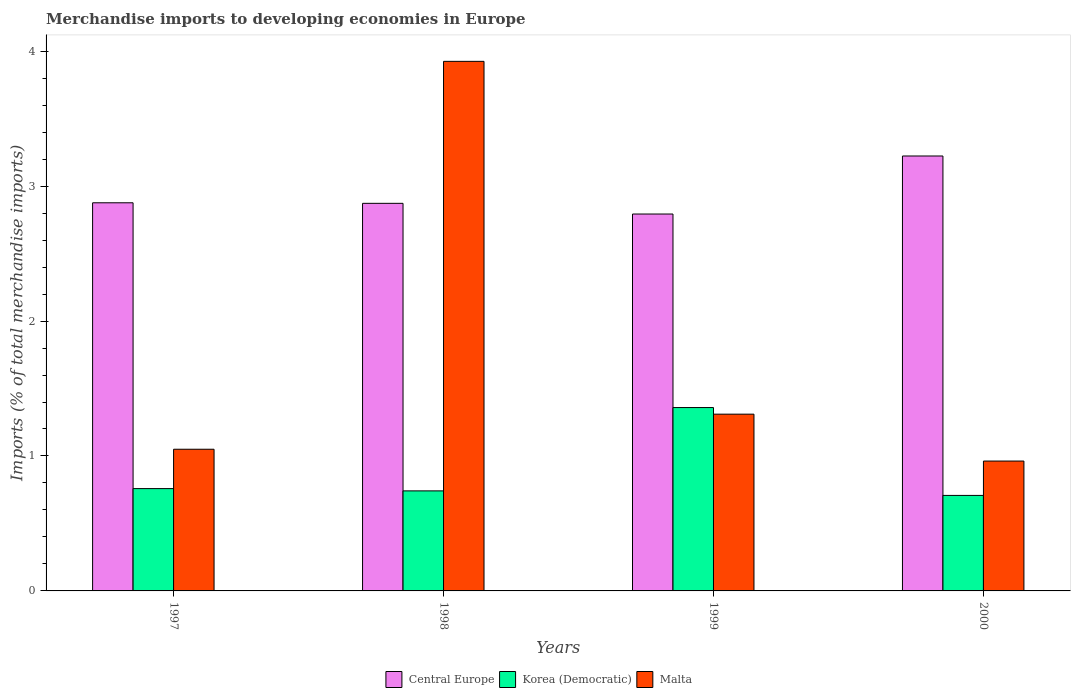How many groups of bars are there?
Your response must be concise. 4. Are the number of bars on each tick of the X-axis equal?
Make the answer very short. Yes. How many bars are there on the 2nd tick from the left?
Your answer should be compact. 3. How many bars are there on the 1st tick from the right?
Offer a very short reply. 3. In how many cases, is the number of bars for a given year not equal to the number of legend labels?
Your answer should be very brief. 0. What is the percentage total merchandise imports in Central Europe in 1999?
Your answer should be very brief. 2.79. Across all years, what is the maximum percentage total merchandise imports in Malta?
Make the answer very short. 3.92. Across all years, what is the minimum percentage total merchandise imports in Korea (Democratic)?
Provide a short and direct response. 0.71. What is the total percentage total merchandise imports in Korea (Democratic) in the graph?
Your answer should be compact. 3.57. What is the difference between the percentage total merchandise imports in Central Europe in 1997 and that in 2000?
Your answer should be very brief. -0.35. What is the difference between the percentage total merchandise imports in Malta in 2000 and the percentage total merchandise imports in Central Europe in 1997?
Make the answer very short. -1.91. What is the average percentage total merchandise imports in Korea (Democratic) per year?
Your answer should be very brief. 0.89. In the year 1998, what is the difference between the percentage total merchandise imports in Korea (Democratic) and percentage total merchandise imports in Central Europe?
Provide a succinct answer. -2.13. In how many years, is the percentage total merchandise imports in Central Europe greater than 3 %?
Provide a succinct answer. 1. What is the ratio of the percentage total merchandise imports in Central Europe in 1999 to that in 2000?
Your answer should be very brief. 0.87. Is the difference between the percentage total merchandise imports in Korea (Democratic) in 1998 and 1999 greater than the difference between the percentage total merchandise imports in Central Europe in 1998 and 1999?
Offer a terse response. No. What is the difference between the highest and the second highest percentage total merchandise imports in Central Europe?
Make the answer very short. 0.35. What is the difference between the highest and the lowest percentage total merchandise imports in Malta?
Keep it short and to the point. 2.96. In how many years, is the percentage total merchandise imports in Korea (Democratic) greater than the average percentage total merchandise imports in Korea (Democratic) taken over all years?
Your answer should be very brief. 1. What does the 3rd bar from the left in 1997 represents?
Your response must be concise. Malta. What does the 1st bar from the right in 1998 represents?
Your answer should be compact. Malta. How many bars are there?
Provide a short and direct response. 12. Where does the legend appear in the graph?
Give a very brief answer. Bottom center. How are the legend labels stacked?
Keep it short and to the point. Horizontal. What is the title of the graph?
Ensure brevity in your answer.  Merchandise imports to developing economies in Europe. Does "Zimbabwe" appear as one of the legend labels in the graph?
Ensure brevity in your answer.  No. What is the label or title of the Y-axis?
Offer a terse response. Imports (% of total merchandise imports). What is the Imports (% of total merchandise imports) in Central Europe in 1997?
Ensure brevity in your answer.  2.88. What is the Imports (% of total merchandise imports) of Korea (Democratic) in 1997?
Your answer should be compact. 0.76. What is the Imports (% of total merchandise imports) in Malta in 1997?
Ensure brevity in your answer.  1.05. What is the Imports (% of total merchandise imports) in Central Europe in 1998?
Offer a very short reply. 2.87. What is the Imports (% of total merchandise imports) of Korea (Democratic) in 1998?
Your response must be concise. 0.74. What is the Imports (% of total merchandise imports) of Malta in 1998?
Your answer should be compact. 3.92. What is the Imports (% of total merchandise imports) in Central Europe in 1999?
Offer a very short reply. 2.79. What is the Imports (% of total merchandise imports) of Korea (Democratic) in 1999?
Keep it short and to the point. 1.36. What is the Imports (% of total merchandise imports) in Malta in 1999?
Make the answer very short. 1.31. What is the Imports (% of total merchandise imports) in Central Europe in 2000?
Give a very brief answer. 3.22. What is the Imports (% of total merchandise imports) of Korea (Democratic) in 2000?
Ensure brevity in your answer.  0.71. What is the Imports (% of total merchandise imports) in Malta in 2000?
Your answer should be compact. 0.96. Across all years, what is the maximum Imports (% of total merchandise imports) in Central Europe?
Offer a terse response. 3.22. Across all years, what is the maximum Imports (% of total merchandise imports) in Korea (Democratic)?
Ensure brevity in your answer.  1.36. Across all years, what is the maximum Imports (% of total merchandise imports) in Malta?
Your answer should be very brief. 3.92. Across all years, what is the minimum Imports (% of total merchandise imports) in Central Europe?
Your response must be concise. 2.79. Across all years, what is the minimum Imports (% of total merchandise imports) of Korea (Democratic)?
Provide a succinct answer. 0.71. Across all years, what is the minimum Imports (% of total merchandise imports) in Malta?
Your answer should be very brief. 0.96. What is the total Imports (% of total merchandise imports) in Central Europe in the graph?
Offer a terse response. 11.76. What is the total Imports (% of total merchandise imports) of Korea (Democratic) in the graph?
Provide a short and direct response. 3.57. What is the total Imports (% of total merchandise imports) in Malta in the graph?
Your response must be concise. 7.25. What is the difference between the Imports (% of total merchandise imports) in Central Europe in 1997 and that in 1998?
Give a very brief answer. 0. What is the difference between the Imports (% of total merchandise imports) in Korea (Democratic) in 1997 and that in 1998?
Your response must be concise. 0.02. What is the difference between the Imports (% of total merchandise imports) of Malta in 1997 and that in 1998?
Your answer should be very brief. -2.87. What is the difference between the Imports (% of total merchandise imports) of Central Europe in 1997 and that in 1999?
Your answer should be compact. 0.08. What is the difference between the Imports (% of total merchandise imports) of Korea (Democratic) in 1997 and that in 1999?
Your answer should be very brief. -0.6. What is the difference between the Imports (% of total merchandise imports) of Malta in 1997 and that in 1999?
Give a very brief answer. -0.26. What is the difference between the Imports (% of total merchandise imports) in Central Europe in 1997 and that in 2000?
Provide a short and direct response. -0.35. What is the difference between the Imports (% of total merchandise imports) in Korea (Democratic) in 1997 and that in 2000?
Give a very brief answer. 0.05. What is the difference between the Imports (% of total merchandise imports) in Malta in 1997 and that in 2000?
Your response must be concise. 0.09. What is the difference between the Imports (% of total merchandise imports) in Central Europe in 1998 and that in 1999?
Ensure brevity in your answer.  0.08. What is the difference between the Imports (% of total merchandise imports) in Korea (Democratic) in 1998 and that in 1999?
Offer a terse response. -0.62. What is the difference between the Imports (% of total merchandise imports) of Malta in 1998 and that in 1999?
Your answer should be very brief. 2.61. What is the difference between the Imports (% of total merchandise imports) of Central Europe in 1998 and that in 2000?
Provide a succinct answer. -0.35. What is the difference between the Imports (% of total merchandise imports) in Korea (Democratic) in 1998 and that in 2000?
Keep it short and to the point. 0.03. What is the difference between the Imports (% of total merchandise imports) of Malta in 1998 and that in 2000?
Your answer should be very brief. 2.96. What is the difference between the Imports (% of total merchandise imports) in Central Europe in 1999 and that in 2000?
Give a very brief answer. -0.43. What is the difference between the Imports (% of total merchandise imports) of Korea (Democratic) in 1999 and that in 2000?
Provide a succinct answer. 0.65. What is the difference between the Imports (% of total merchandise imports) of Malta in 1999 and that in 2000?
Keep it short and to the point. 0.35. What is the difference between the Imports (% of total merchandise imports) in Central Europe in 1997 and the Imports (% of total merchandise imports) in Korea (Democratic) in 1998?
Keep it short and to the point. 2.13. What is the difference between the Imports (% of total merchandise imports) of Central Europe in 1997 and the Imports (% of total merchandise imports) of Malta in 1998?
Your answer should be very brief. -1.05. What is the difference between the Imports (% of total merchandise imports) of Korea (Democratic) in 1997 and the Imports (% of total merchandise imports) of Malta in 1998?
Provide a short and direct response. -3.17. What is the difference between the Imports (% of total merchandise imports) in Central Europe in 1997 and the Imports (% of total merchandise imports) in Korea (Democratic) in 1999?
Provide a short and direct response. 1.52. What is the difference between the Imports (% of total merchandise imports) of Central Europe in 1997 and the Imports (% of total merchandise imports) of Malta in 1999?
Your answer should be very brief. 1.57. What is the difference between the Imports (% of total merchandise imports) of Korea (Democratic) in 1997 and the Imports (% of total merchandise imports) of Malta in 1999?
Offer a terse response. -0.55. What is the difference between the Imports (% of total merchandise imports) of Central Europe in 1997 and the Imports (% of total merchandise imports) of Korea (Democratic) in 2000?
Give a very brief answer. 2.17. What is the difference between the Imports (% of total merchandise imports) of Central Europe in 1997 and the Imports (% of total merchandise imports) of Malta in 2000?
Give a very brief answer. 1.91. What is the difference between the Imports (% of total merchandise imports) in Korea (Democratic) in 1997 and the Imports (% of total merchandise imports) in Malta in 2000?
Give a very brief answer. -0.2. What is the difference between the Imports (% of total merchandise imports) of Central Europe in 1998 and the Imports (% of total merchandise imports) of Korea (Democratic) in 1999?
Ensure brevity in your answer.  1.51. What is the difference between the Imports (% of total merchandise imports) in Central Europe in 1998 and the Imports (% of total merchandise imports) in Malta in 1999?
Ensure brevity in your answer.  1.56. What is the difference between the Imports (% of total merchandise imports) of Korea (Democratic) in 1998 and the Imports (% of total merchandise imports) of Malta in 1999?
Ensure brevity in your answer.  -0.57. What is the difference between the Imports (% of total merchandise imports) in Central Europe in 1998 and the Imports (% of total merchandise imports) in Korea (Democratic) in 2000?
Make the answer very short. 2.16. What is the difference between the Imports (% of total merchandise imports) of Central Europe in 1998 and the Imports (% of total merchandise imports) of Malta in 2000?
Your response must be concise. 1.91. What is the difference between the Imports (% of total merchandise imports) in Korea (Democratic) in 1998 and the Imports (% of total merchandise imports) in Malta in 2000?
Make the answer very short. -0.22. What is the difference between the Imports (% of total merchandise imports) in Central Europe in 1999 and the Imports (% of total merchandise imports) in Korea (Democratic) in 2000?
Your answer should be compact. 2.09. What is the difference between the Imports (% of total merchandise imports) in Central Europe in 1999 and the Imports (% of total merchandise imports) in Malta in 2000?
Your answer should be very brief. 1.83. What is the difference between the Imports (% of total merchandise imports) of Korea (Democratic) in 1999 and the Imports (% of total merchandise imports) of Malta in 2000?
Your response must be concise. 0.4. What is the average Imports (% of total merchandise imports) in Central Europe per year?
Provide a short and direct response. 2.94. What is the average Imports (% of total merchandise imports) in Korea (Democratic) per year?
Make the answer very short. 0.89. What is the average Imports (% of total merchandise imports) of Malta per year?
Give a very brief answer. 1.81. In the year 1997, what is the difference between the Imports (% of total merchandise imports) in Central Europe and Imports (% of total merchandise imports) in Korea (Democratic)?
Your response must be concise. 2.12. In the year 1997, what is the difference between the Imports (% of total merchandise imports) in Central Europe and Imports (% of total merchandise imports) in Malta?
Provide a short and direct response. 1.83. In the year 1997, what is the difference between the Imports (% of total merchandise imports) in Korea (Democratic) and Imports (% of total merchandise imports) in Malta?
Your answer should be very brief. -0.29. In the year 1998, what is the difference between the Imports (% of total merchandise imports) in Central Europe and Imports (% of total merchandise imports) in Korea (Democratic)?
Provide a succinct answer. 2.13. In the year 1998, what is the difference between the Imports (% of total merchandise imports) of Central Europe and Imports (% of total merchandise imports) of Malta?
Provide a succinct answer. -1.05. In the year 1998, what is the difference between the Imports (% of total merchandise imports) of Korea (Democratic) and Imports (% of total merchandise imports) of Malta?
Your response must be concise. -3.18. In the year 1999, what is the difference between the Imports (% of total merchandise imports) of Central Europe and Imports (% of total merchandise imports) of Korea (Democratic)?
Offer a very short reply. 1.43. In the year 1999, what is the difference between the Imports (% of total merchandise imports) in Central Europe and Imports (% of total merchandise imports) in Malta?
Offer a very short reply. 1.48. In the year 1999, what is the difference between the Imports (% of total merchandise imports) in Korea (Democratic) and Imports (% of total merchandise imports) in Malta?
Ensure brevity in your answer.  0.05. In the year 2000, what is the difference between the Imports (% of total merchandise imports) in Central Europe and Imports (% of total merchandise imports) in Korea (Democratic)?
Ensure brevity in your answer.  2.52. In the year 2000, what is the difference between the Imports (% of total merchandise imports) in Central Europe and Imports (% of total merchandise imports) in Malta?
Provide a short and direct response. 2.26. In the year 2000, what is the difference between the Imports (% of total merchandise imports) in Korea (Democratic) and Imports (% of total merchandise imports) in Malta?
Ensure brevity in your answer.  -0.25. What is the ratio of the Imports (% of total merchandise imports) in Korea (Democratic) in 1997 to that in 1998?
Offer a very short reply. 1.02. What is the ratio of the Imports (% of total merchandise imports) in Malta in 1997 to that in 1998?
Offer a terse response. 0.27. What is the ratio of the Imports (% of total merchandise imports) in Central Europe in 1997 to that in 1999?
Provide a short and direct response. 1.03. What is the ratio of the Imports (% of total merchandise imports) of Korea (Democratic) in 1997 to that in 1999?
Offer a terse response. 0.56. What is the ratio of the Imports (% of total merchandise imports) in Malta in 1997 to that in 1999?
Keep it short and to the point. 0.8. What is the ratio of the Imports (% of total merchandise imports) of Central Europe in 1997 to that in 2000?
Offer a very short reply. 0.89. What is the ratio of the Imports (% of total merchandise imports) in Korea (Democratic) in 1997 to that in 2000?
Your answer should be very brief. 1.07. What is the ratio of the Imports (% of total merchandise imports) in Malta in 1997 to that in 2000?
Offer a terse response. 1.09. What is the ratio of the Imports (% of total merchandise imports) of Central Europe in 1998 to that in 1999?
Provide a short and direct response. 1.03. What is the ratio of the Imports (% of total merchandise imports) in Korea (Democratic) in 1998 to that in 1999?
Provide a succinct answer. 0.55. What is the ratio of the Imports (% of total merchandise imports) of Malta in 1998 to that in 1999?
Your response must be concise. 3. What is the ratio of the Imports (% of total merchandise imports) in Central Europe in 1998 to that in 2000?
Provide a short and direct response. 0.89. What is the ratio of the Imports (% of total merchandise imports) of Korea (Democratic) in 1998 to that in 2000?
Keep it short and to the point. 1.05. What is the ratio of the Imports (% of total merchandise imports) in Malta in 1998 to that in 2000?
Your response must be concise. 4.08. What is the ratio of the Imports (% of total merchandise imports) of Central Europe in 1999 to that in 2000?
Offer a very short reply. 0.87. What is the ratio of the Imports (% of total merchandise imports) of Korea (Democratic) in 1999 to that in 2000?
Keep it short and to the point. 1.92. What is the ratio of the Imports (% of total merchandise imports) in Malta in 1999 to that in 2000?
Provide a short and direct response. 1.36. What is the difference between the highest and the second highest Imports (% of total merchandise imports) in Central Europe?
Offer a very short reply. 0.35. What is the difference between the highest and the second highest Imports (% of total merchandise imports) of Korea (Democratic)?
Your response must be concise. 0.6. What is the difference between the highest and the second highest Imports (% of total merchandise imports) of Malta?
Offer a very short reply. 2.61. What is the difference between the highest and the lowest Imports (% of total merchandise imports) of Central Europe?
Your answer should be very brief. 0.43. What is the difference between the highest and the lowest Imports (% of total merchandise imports) in Korea (Democratic)?
Provide a short and direct response. 0.65. What is the difference between the highest and the lowest Imports (% of total merchandise imports) in Malta?
Ensure brevity in your answer.  2.96. 